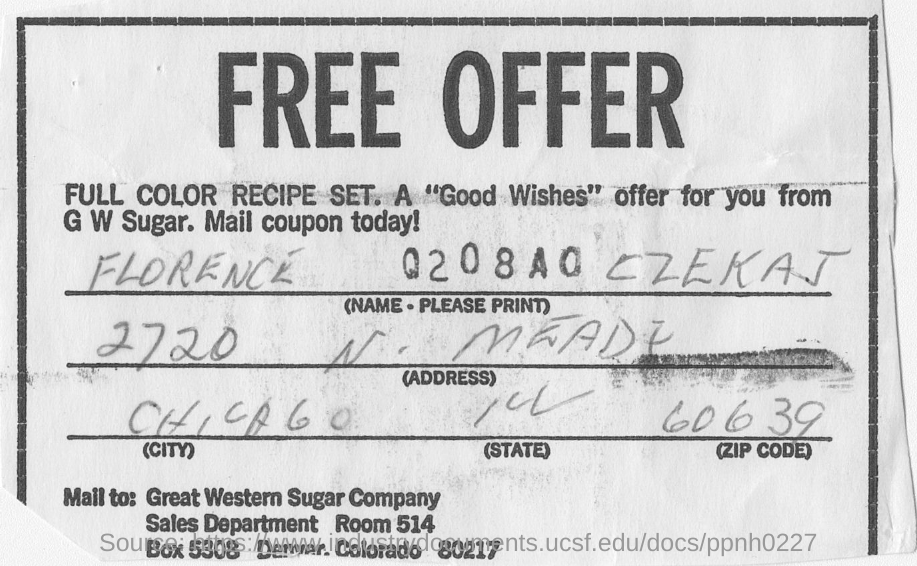Which city is FLORENCE CZEKAJ located in?
Your answer should be compact. CHICAGO. 